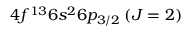Convert formula to latex. <formula><loc_0><loc_0><loc_500><loc_500>4 f ^ { 1 3 } 6 s ^ { 2 } 6 p _ { 3 / 2 } \, ( J = 2 )</formula> 